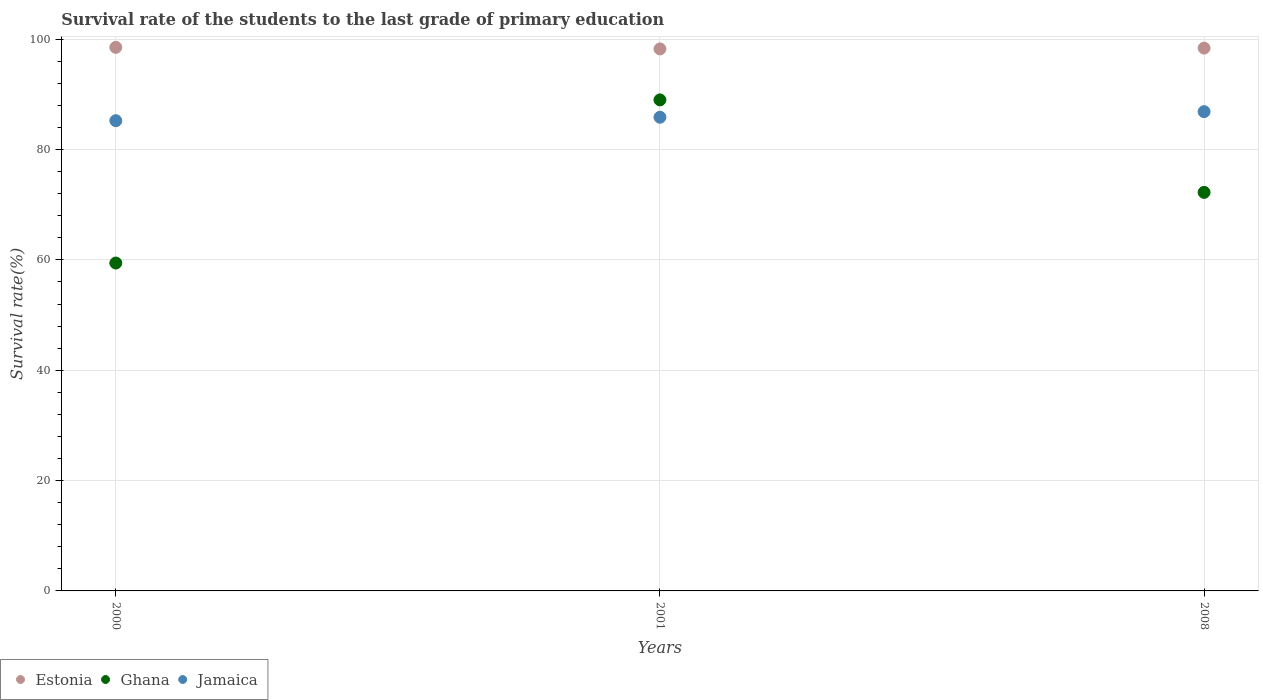How many different coloured dotlines are there?
Your response must be concise. 3. Is the number of dotlines equal to the number of legend labels?
Keep it short and to the point. Yes. What is the survival rate of the students in Estonia in 2008?
Provide a succinct answer. 98.38. Across all years, what is the maximum survival rate of the students in Ghana?
Give a very brief answer. 88.99. Across all years, what is the minimum survival rate of the students in Jamaica?
Offer a very short reply. 85.22. In which year was the survival rate of the students in Ghana maximum?
Provide a short and direct response. 2001. What is the total survival rate of the students in Estonia in the graph?
Provide a succinct answer. 295.12. What is the difference between the survival rate of the students in Jamaica in 2001 and that in 2008?
Give a very brief answer. -1.01. What is the difference between the survival rate of the students in Jamaica in 2001 and the survival rate of the students in Estonia in 2008?
Make the answer very short. -12.53. What is the average survival rate of the students in Estonia per year?
Keep it short and to the point. 98.37. In the year 2008, what is the difference between the survival rate of the students in Jamaica and survival rate of the students in Estonia?
Your response must be concise. -11.52. In how many years, is the survival rate of the students in Jamaica greater than 92 %?
Offer a terse response. 0. What is the ratio of the survival rate of the students in Jamaica in 2001 to that in 2008?
Your answer should be compact. 0.99. Is the survival rate of the students in Ghana in 2001 less than that in 2008?
Provide a succinct answer. No. What is the difference between the highest and the second highest survival rate of the students in Jamaica?
Ensure brevity in your answer.  1.01. What is the difference between the highest and the lowest survival rate of the students in Jamaica?
Your answer should be very brief. 1.64. Is the sum of the survival rate of the students in Jamaica in 2001 and 2008 greater than the maximum survival rate of the students in Estonia across all years?
Make the answer very short. Yes. Does the survival rate of the students in Jamaica monotonically increase over the years?
Provide a short and direct response. Yes. Is the survival rate of the students in Ghana strictly greater than the survival rate of the students in Estonia over the years?
Provide a short and direct response. No. Is the survival rate of the students in Jamaica strictly less than the survival rate of the students in Estonia over the years?
Your answer should be very brief. Yes. How many dotlines are there?
Give a very brief answer. 3. Does the graph contain any zero values?
Offer a terse response. No. Where does the legend appear in the graph?
Keep it short and to the point. Bottom left. How are the legend labels stacked?
Your response must be concise. Horizontal. What is the title of the graph?
Offer a terse response. Survival rate of the students to the last grade of primary education. What is the label or title of the X-axis?
Your answer should be very brief. Years. What is the label or title of the Y-axis?
Ensure brevity in your answer.  Survival rate(%). What is the Survival rate(%) of Estonia in 2000?
Keep it short and to the point. 98.51. What is the Survival rate(%) of Ghana in 2000?
Your answer should be compact. 59.42. What is the Survival rate(%) of Jamaica in 2000?
Offer a terse response. 85.22. What is the Survival rate(%) of Estonia in 2001?
Keep it short and to the point. 98.23. What is the Survival rate(%) in Ghana in 2001?
Offer a very short reply. 88.99. What is the Survival rate(%) of Jamaica in 2001?
Ensure brevity in your answer.  85.85. What is the Survival rate(%) of Estonia in 2008?
Offer a very short reply. 98.38. What is the Survival rate(%) in Ghana in 2008?
Keep it short and to the point. 72.23. What is the Survival rate(%) of Jamaica in 2008?
Your response must be concise. 86.86. Across all years, what is the maximum Survival rate(%) of Estonia?
Provide a succinct answer. 98.51. Across all years, what is the maximum Survival rate(%) in Ghana?
Give a very brief answer. 88.99. Across all years, what is the maximum Survival rate(%) of Jamaica?
Ensure brevity in your answer.  86.86. Across all years, what is the minimum Survival rate(%) in Estonia?
Provide a short and direct response. 98.23. Across all years, what is the minimum Survival rate(%) in Ghana?
Offer a very short reply. 59.42. Across all years, what is the minimum Survival rate(%) of Jamaica?
Offer a terse response. 85.22. What is the total Survival rate(%) of Estonia in the graph?
Ensure brevity in your answer.  295.12. What is the total Survival rate(%) of Ghana in the graph?
Your answer should be compact. 220.65. What is the total Survival rate(%) in Jamaica in the graph?
Provide a short and direct response. 257.93. What is the difference between the Survival rate(%) in Estonia in 2000 and that in 2001?
Keep it short and to the point. 0.28. What is the difference between the Survival rate(%) of Ghana in 2000 and that in 2001?
Offer a very short reply. -29.57. What is the difference between the Survival rate(%) of Jamaica in 2000 and that in 2001?
Keep it short and to the point. -0.63. What is the difference between the Survival rate(%) in Estonia in 2000 and that in 2008?
Your answer should be very brief. 0.13. What is the difference between the Survival rate(%) in Ghana in 2000 and that in 2008?
Make the answer very short. -12.81. What is the difference between the Survival rate(%) of Jamaica in 2000 and that in 2008?
Provide a short and direct response. -1.64. What is the difference between the Survival rate(%) in Estonia in 2001 and that in 2008?
Keep it short and to the point. -0.15. What is the difference between the Survival rate(%) in Ghana in 2001 and that in 2008?
Give a very brief answer. 16.76. What is the difference between the Survival rate(%) of Jamaica in 2001 and that in 2008?
Your response must be concise. -1.01. What is the difference between the Survival rate(%) in Estonia in 2000 and the Survival rate(%) in Ghana in 2001?
Offer a terse response. 9.52. What is the difference between the Survival rate(%) of Estonia in 2000 and the Survival rate(%) of Jamaica in 2001?
Offer a terse response. 12.66. What is the difference between the Survival rate(%) in Ghana in 2000 and the Survival rate(%) in Jamaica in 2001?
Make the answer very short. -26.43. What is the difference between the Survival rate(%) in Estonia in 2000 and the Survival rate(%) in Ghana in 2008?
Make the answer very short. 26.28. What is the difference between the Survival rate(%) in Estonia in 2000 and the Survival rate(%) in Jamaica in 2008?
Your response must be concise. 11.65. What is the difference between the Survival rate(%) in Ghana in 2000 and the Survival rate(%) in Jamaica in 2008?
Offer a terse response. -27.44. What is the difference between the Survival rate(%) in Estonia in 2001 and the Survival rate(%) in Ghana in 2008?
Offer a terse response. 26. What is the difference between the Survival rate(%) in Estonia in 2001 and the Survival rate(%) in Jamaica in 2008?
Offer a very short reply. 11.37. What is the difference between the Survival rate(%) of Ghana in 2001 and the Survival rate(%) of Jamaica in 2008?
Your answer should be compact. 2.13. What is the average Survival rate(%) of Estonia per year?
Offer a very short reply. 98.37. What is the average Survival rate(%) of Ghana per year?
Ensure brevity in your answer.  73.55. What is the average Survival rate(%) of Jamaica per year?
Provide a short and direct response. 85.98. In the year 2000, what is the difference between the Survival rate(%) in Estonia and Survival rate(%) in Ghana?
Your answer should be very brief. 39.09. In the year 2000, what is the difference between the Survival rate(%) in Estonia and Survival rate(%) in Jamaica?
Provide a short and direct response. 13.29. In the year 2000, what is the difference between the Survival rate(%) in Ghana and Survival rate(%) in Jamaica?
Your answer should be very brief. -25.8. In the year 2001, what is the difference between the Survival rate(%) in Estonia and Survival rate(%) in Ghana?
Your response must be concise. 9.24. In the year 2001, what is the difference between the Survival rate(%) in Estonia and Survival rate(%) in Jamaica?
Provide a succinct answer. 12.38. In the year 2001, what is the difference between the Survival rate(%) in Ghana and Survival rate(%) in Jamaica?
Keep it short and to the point. 3.14. In the year 2008, what is the difference between the Survival rate(%) in Estonia and Survival rate(%) in Ghana?
Give a very brief answer. 26.15. In the year 2008, what is the difference between the Survival rate(%) in Estonia and Survival rate(%) in Jamaica?
Your answer should be compact. 11.52. In the year 2008, what is the difference between the Survival rate(%) of Ghana and Survival rate(%) of Jamaica?
Make the answer very short. -14.63. What is the ratio of the Survival rate(%) in Estonia in 2000 to that in 2001?
Make the answer very short. 1. What is the ratio of the Survival rate(%) in Ghana in 2000 to that in 2001?
Offer a very short reply. 0.67. What is the ratio of the Survival rate(%) in Ghana in 2000 to that in 2008?
Provide a succinct answer. 0.82. What is the ratio of the Survival rate(%) in Jamaica in 2000 to that in 2008?
Offer a very short reply. 0.98. What is the ratio of the Survival rate(%) of Estonia in 2001 to that in 2008?
Your answer should be compact. 1. What is the ratio of the Survival rate(%) in Ghana in 2001 to that in 2008?
Offer a very short reply. 1.23. What is the ratio of the Survival rate(%) of Jamaica in 2001 to that in 2008?
Offer a very short reply. 0.99. What is the difference between the highest and the second highest Survival rate(%) of Estonia?
Offer a very short reply. 0.13. What is the difference between the highest and the second highest Survival rate(%) of Ghana?
Your answer should be compact. 16.76. What is the difference between the highest and the second highest Survival rate(%) in Jamaica?
Ensure brevity in your answer.  1.01. What is the difference between the highest and the lowest Survival rate(%) in Estonia?
Offer a terse response. 0.28. What is the difference between the highest and the lowest Survival rate(%) in Ghana?
Make the answer very short. 29.57. What is the difference between the highest and the lowest Survival rate(%) of Jamaica?
Your answer should be very brief. 1.64. 